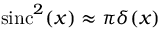<formula> <loc_0><loc_0><loc_500><loc_500>\sin c ^ { 2 } ( x ) \approx \pi \delta ( x )</formula> 